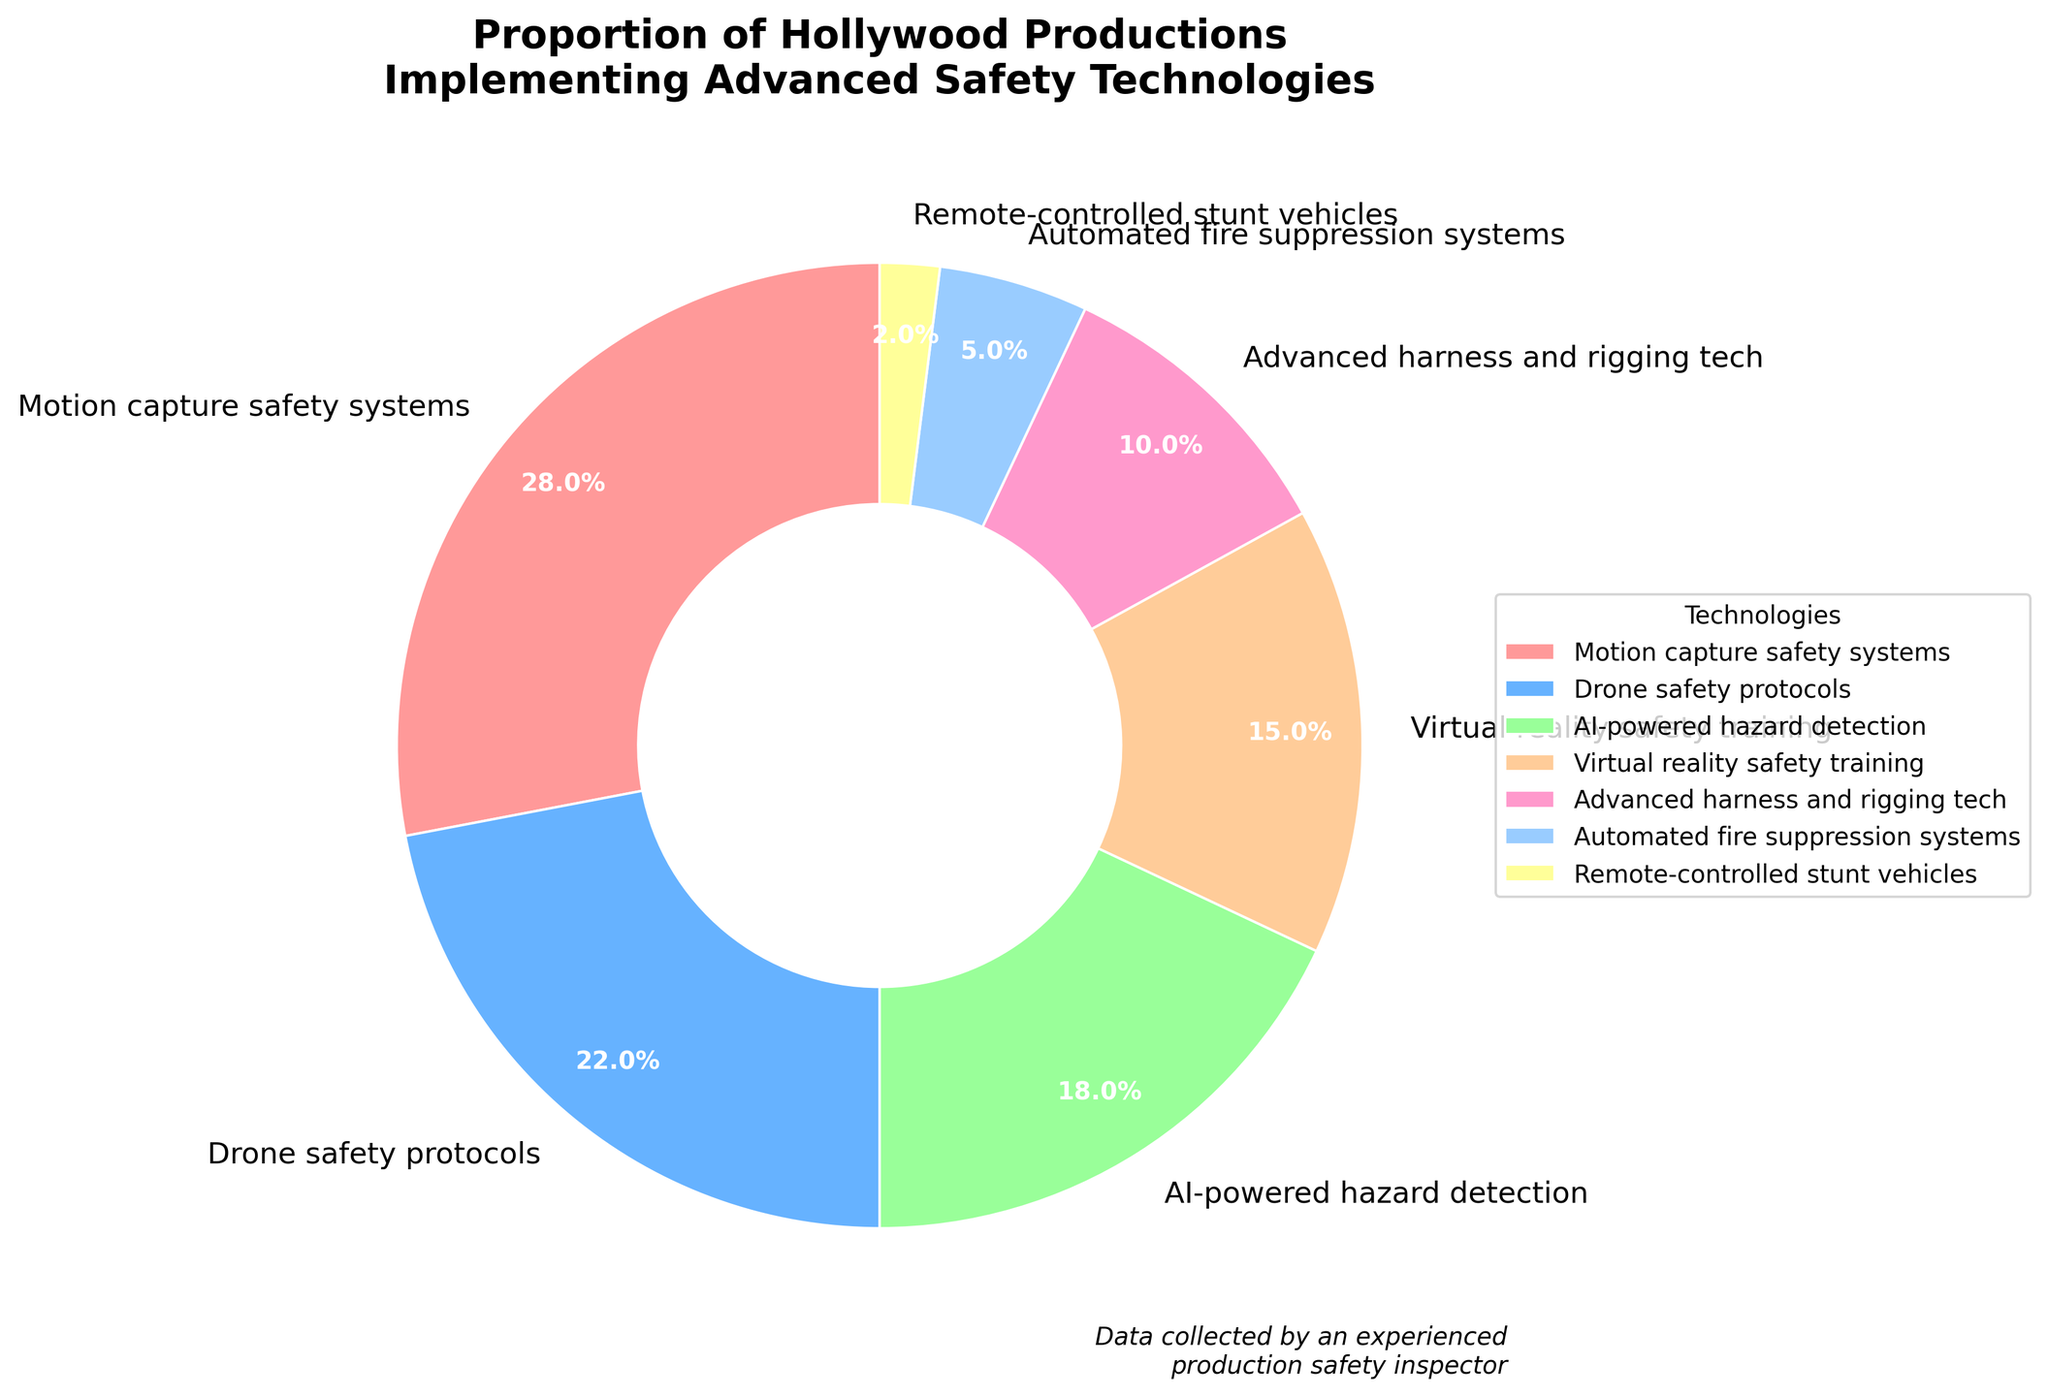What's the most commonly implemented advanced safety technology in Hollywood productions? The chart shows different safety technologies and their percentages, with "Motion capture safety systems" having the highest percentage of 28%.
Answer: Motion capture safety systems Which technologies together constitute more than 50% of implementations? Adding the percentages of the highest technologies until the sum exceeds 50%: Motion capture safety systems (28%) + Drone safety protocols (22%) = 50%. Since we need more than 50%, both technologies together make up more than 50%.
Answer: Motion capture safety systems and Drone safety protocols What is the total percentage for AI-powered hazard detection and Virtual reality safety training combined? Sum the percentages of AI-powered hazard detection (18%) and Virtual reality safety training (15%): 18% + 15% = 33%.
Answer: 33% Are there more productions implementing Advanced harness and rigging tech or Automated fire suppression systems? Compare the percentages: Advanced harness and rigging tech (10%) is greater than Automated fire suppression systems (5%).
Answer: Advanced harness and rigging tech What's the smallest category in the pie chart? The smallest slice of the pie represents Remote-controlled stunt vehicles with 2%.
Answer: Remote-controlled stunt vehicles How much more percentage is spent on Motion capture safety systems compared to Automated fire suppression systems? Subtraction: Motion capture safety systems (28%) - Automated fire suppression systems (5%) = 23%.
Answer: 23% Which color in the pie chart represents Drone safety protocols? Drone safety protocols is the second segment in the chart with a percentage of 22%, represented in the second listed color, which is light blue.
Answer: Light blue Which technologies have a combined total less than that of Drone safety protocols? Adding several smaller segments: Automated fire suppression systems (5%) + Remote-controlled stunt vehicles (2%) = 7%, which is less than Drone safety protocols (22%).
Answer: Automated fire suppression systems and Remote-controlled stunt vehicles Is the percentage for Virtual reality safety training greater than or less than the average percentage of all the listed technologies? First, calculate the average percentage: (28% + 22% + 18% + 15% + 10% + 5% + 2%)/7 = 100/7 ≈ 14.3%. Virtual reality safety training at 15% is slightly greater than the average.
Answer: Greater Summing the three least implemented technologies, how do they compare to Motion capture safety systems? Add the percentages of the three least implemented technologies: Automated fire suppression systems (5%) + Advanced harness and rigging tech (10%) + Remote-controlled stunt vehicles (2%) = 17%. Compare this to Motion capture safety systems (28%): 17% is less than 28%.
Answer: Less 